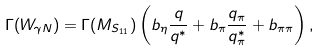<formula> <loc_0><loc_0><loc_500><loc_500>\Gamma ( W _ { \gamma N } ) = \Gamma ( M _ { S _ { 1 1 } } ) \left ( b _ { \eta } \frac { q } { q ^ { * } } + b _ { \pi } \frac { q _ { \pi } } { q _ { \pi } ^ { * } } + b _ { \pi \pi } \right ) ,</formula> 